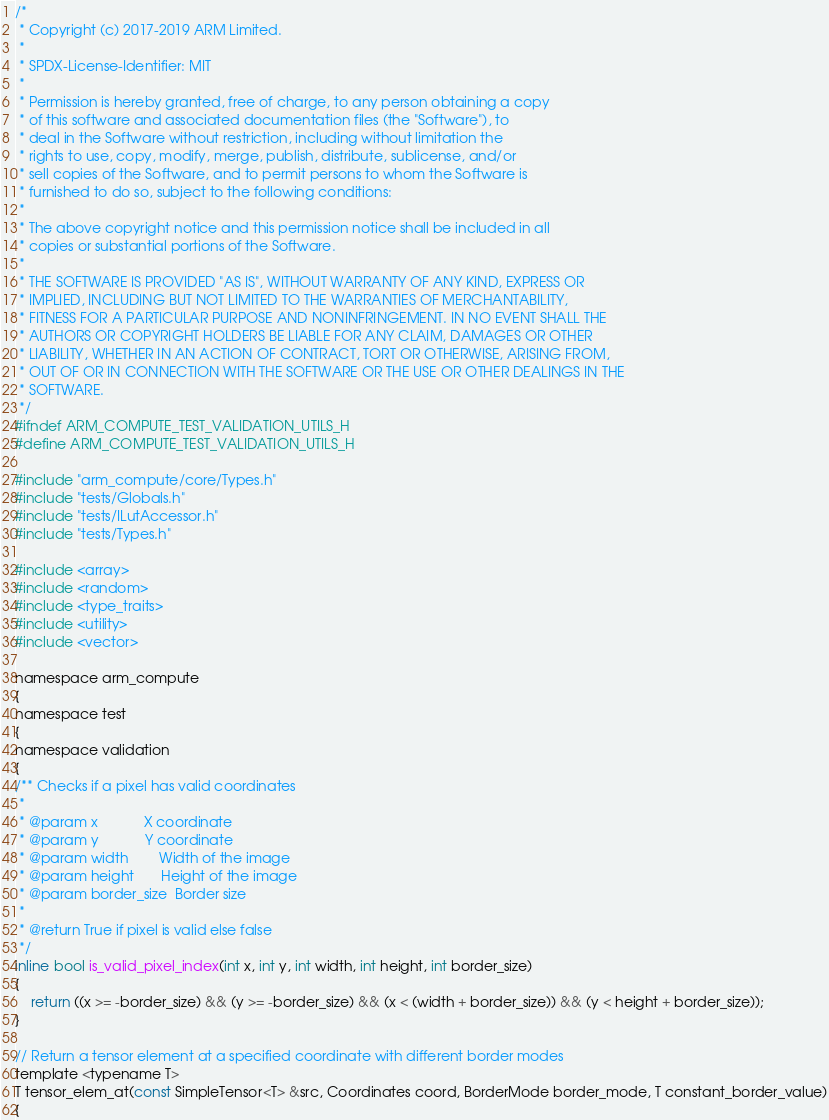Convert code to text. <code><loc_0><loc_0><loc_500><loc_500><_C_>/*
 * Copyright (c) 2017-2019 ARM Limited.
 *
 * SPDX-License-Identifier: MIT
 *
 * Permission is hereby granted, free of charge, to any person obtaining a copy
 * of this software and associated documentation files (the "Software"), to
 * deal in the Software without restriction, including without limitation the
 * rights to use, copy, modify, merge, publish, distribute, sublicense, and/or
 * sell copies of the Software, and to permit persons to whom the Software is
 * furnished to do so, subject to the following conditions:
 *
 * The above copyright notice and this permission notice shall be included in all
 * copies or substantial portions of the Software.
 *
 * THE SOFTWARE IS PROVIDED "AS IS", WITHOUT WARRANTY OF ANY KIND, EXPRESS OR
 * IMPLIED, INCLUDING BUT NOT LIMITED TO THE WARRANTIES OF MERCHANTABILITY,
 * FITNESS FOR A PARTICULAR PURPOSE AND NONINFRINGEMENT. IN NO EVENT SHALL THE
 * AUTHORS OR COPYRIGHT HOLDERS BE LIABLE FOR ANY CLAIM, DAMAGES OR OTHER
 * LIABILITY, WHETHER IN AN ACTION OF CONTRACT, TORT OR OTHERWISE, ARISING FROM,
 * OUT OF OR IN CONNECTION WITH THE SOFTWARE OR THE USE OR OTHER DEALINGS IN THE
 * SOFTWARE.
 */
#ifndef ARM_COMPUTE_TEST_VALIDATION_UTILS_H
#define ARM_COMPUTE_TEST_VALIDATION_UTILS_H

#include "arm_compute/core/Types.h"
#include "tests/Globals.h"
#include "tests/ILutAccessor.h"
#include "tests/Types.h"

#include <array>
#include <random>
#include <type_traits>
#include <utility>
#include <vector>

namespace arm_compute
{
namespace test
{
namespace validation
{
/** Checks if a pixel has valid coordinates
 *
 * @param x            X coordinate
 * @param y            Y coordinate
 * @param width        Width of the image
 * @param height       Height of the image
 * @param border_size  Border size
 *
 * @return True if pixel is valid else false
 */
inline bool is_valid_pixel_index(int x, int y, int width, int height, int border_size)
{
    return ((x >= -border_size) && (y >= -border_size) && (x < (width + border_size)) && (y < height + border_size));
}

// Return a tensor element at a specified coordinate with different border modes
template <typename T>
T tensor_elem_at(const SimpleTensor<T> &src, Coordinates coord, BorderMode border_mode, T constant_border_value)
{</code> 